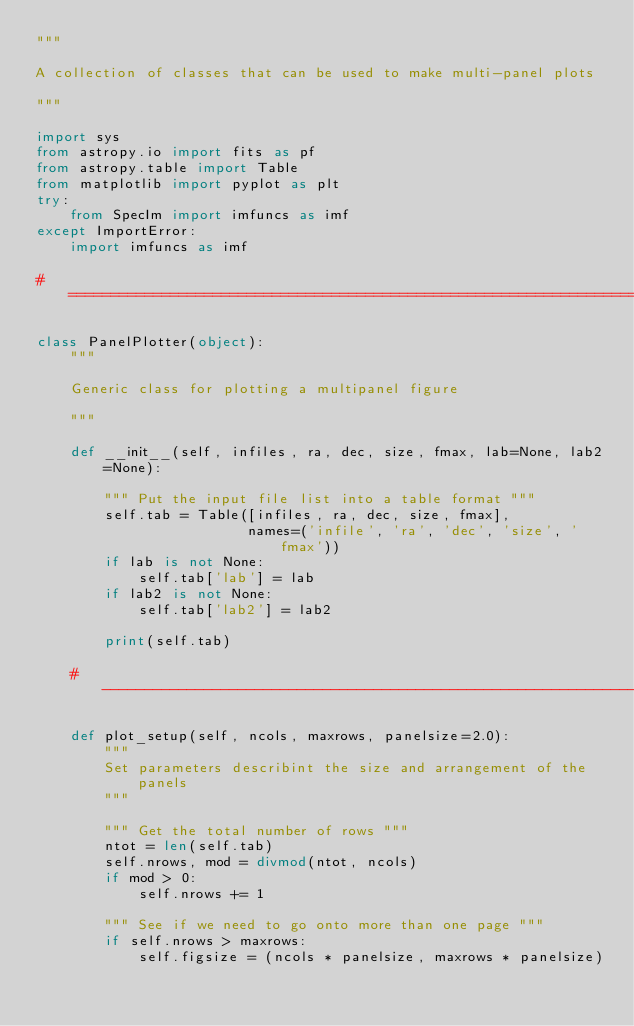<code> <loc_0><loc_0><loc_500><loc_500><_Python_>"""

A collection of classes that can be used to make multi-panel plots

"""

import sys
from astropy.io import fits as pf
from astropy.table import Table
from matplotlib import pyplot as plt
try:
    from SpecIm import imfuncs as imf
except ImportError:
    import imfuncs as imf

# ===========================================================================

class PanelPlotter(object):
    """

    Generic class for plotting a multipanel figure

    """

    def __init__(self, infiles, ra, dec, size, fmax, lab=None, lab2=None):

        """ Put the input file list into a table format """
        self.tab = Table([infiles, ra, dec, size, fmax],
                         names=('infile', 'ra', 'dec', 'size', 'fmax'))
        if lab is not None:
            self.tab['lab'] = lab
        if lab2 is not None:
            self.tab['lab2'] = lab2

        print(self.tab)

    # -----------------------------------------------------------------------

    def plot_setup(self, ncols, maxrows, panelsize=2.0):
        """
        Set parameters describint the size and arrangement of the panels
        """

        """ Get the total number of rows """
        ntot = len(self.tab)
        self.nrows, mod = divmod(ntot, ncols)
        if mod > 0:
            self.nrows += 1

        """ See if we need to go onto more than one page """
        if self.nrows > maxrows:
            self.figsize = (ncols * panelsize, maxrows * panelsize)</code> 